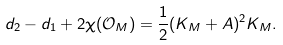Convert formula to latex. <formula><loc_0><loc_0><loc_500><loc_500>d _ { 2 } - d _ { 1 } + 2 \chi ( \mathcal { O } _ { M } ) = \frac { 1 } { 2 } ( K _ { M } + A ) ^ { 2 } K _ { M } .</formula> 